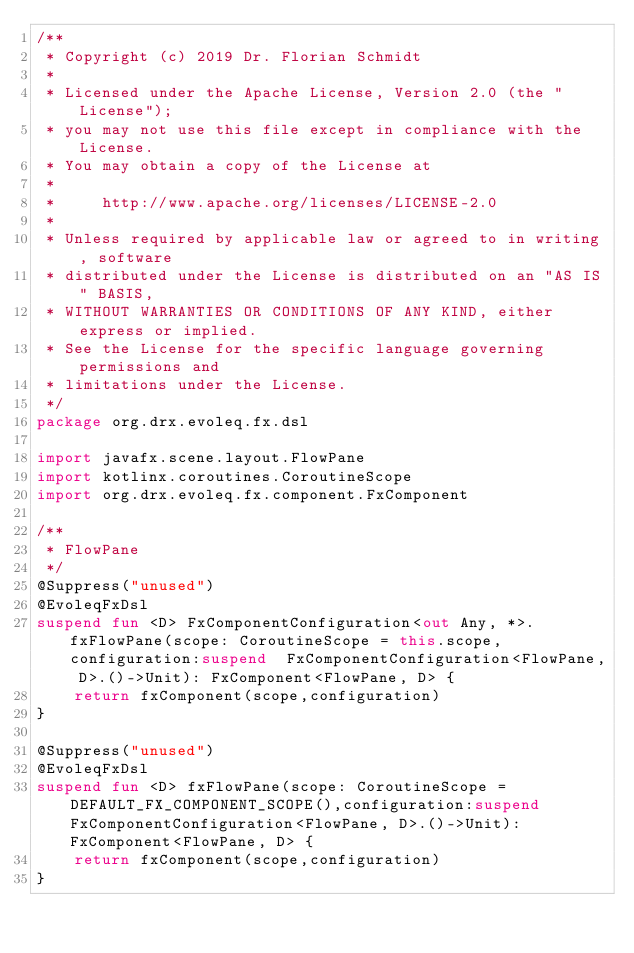<code> <loc_0><loc_0><loc_500><loc_500><_Kotlin_>/**
 * Copyright (c) 2019 Dr. Florian Schmidt
 *
 * Licensed under the Apache License, Version 2.0 (the "License");
 * you may not use this file except in compliance with the License.
 * You may obtain a copy of the License at
 *
 *     http://www.apache.org/licenses/LICENSE-2.0
 *
 * Unless required by applicable law or agreed to in writing, software
 * distributed under the License is distributed on an "AS IS" BASIS,
 * WITHOUT WARRANTIES OR CONDITIONS OF ANY KIND, either express or implied.
 * See the License for the specific language governing permissions and
 * limitations under the License.
 */
package org.drx.evoleq.fx.dsl

import javafx.scene.layout.FlowPane
import kotlinx.coroutines.CoroutineScope
import org.drx.evoleq.fx.component.FxComponent

/**
 * FlowPane
 */
@Suppress("unused")
@EvoleqFxDsl
suspend fun <D> FxComponentConfiguration<out Any, *>.fxFlowPane(scope: CoroutineScope = this.scope, configuration:suspend  FxComponentConfiguration<FlowPane, D>.()->Unit): FxComponent<FlowPane, D> {
    return fxComponent(scope,configuration)
}

@Suppress("unused")
@EvoleqFxDsl
suspend fun <D> fxFlowPane(scope: CoroutineScope = DEFAULT_FX_COMPONENT_SCOPE(),configuration:suspend  FxComponentConfiguration<FlowPane, D>.()->Unit): FxComponent<FlowPane, D> {
    return fxComponent(scope,configuration)
}</code> 